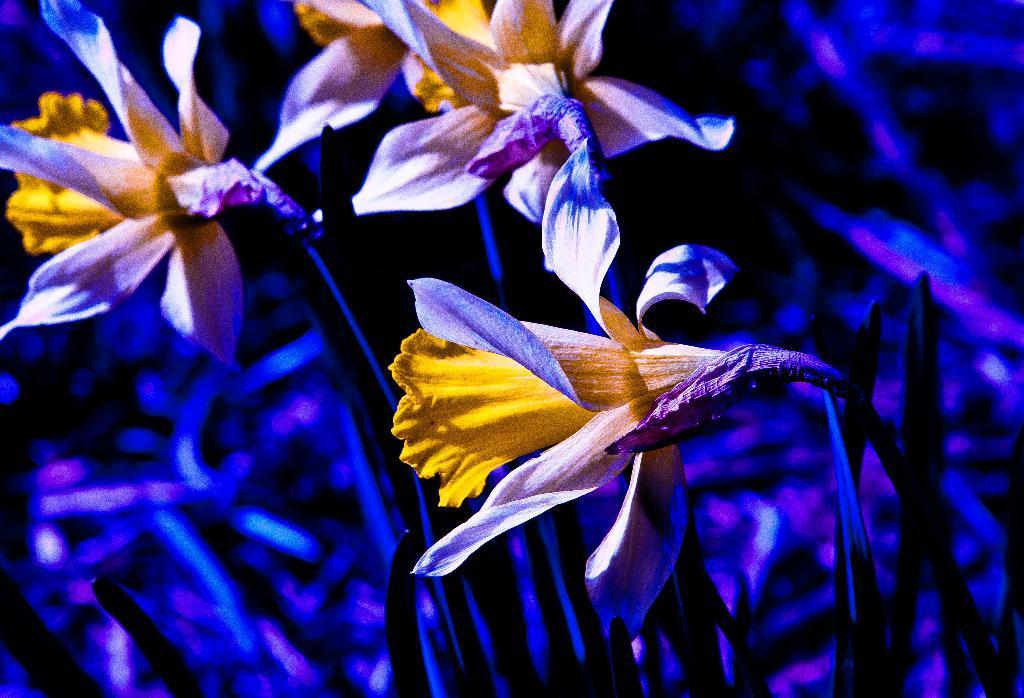How would you summarize this image in a sentence or two? In this picture we can see few flowers and blurry background. 